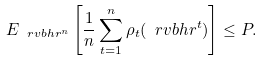<formula> <loc_0><loc_0><loc_500><loc_500>E _ { \ r v b h r ^ { n } } \left [ \frac { 1 } { n } \sum _ { t = 1 } ^ { n } \rho _ { t } ( \ r v b h r ^ { t } ) \right ] \leq P .</formula> 